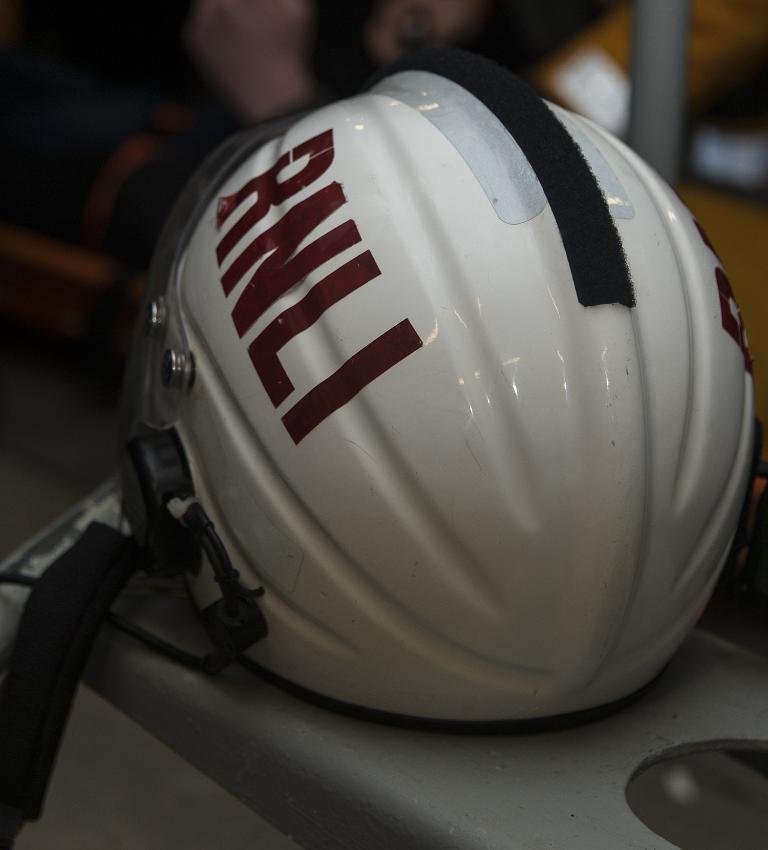Please provide a concise description of this image. There is a white color helmet placed on a table. And the background is blurred. 